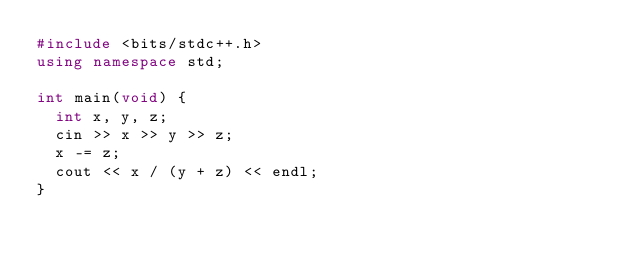Convert code to text. <code><loc_0><loc_0><loc_500><loc_500><_C++_>#include <bits/stdc++.h>
using namespace std;

int main(void) {
  int x, y, z;
  cin >> x >> y >> z;
  x -= z;
  cout << x / (y + z) << endl;
}</code> 